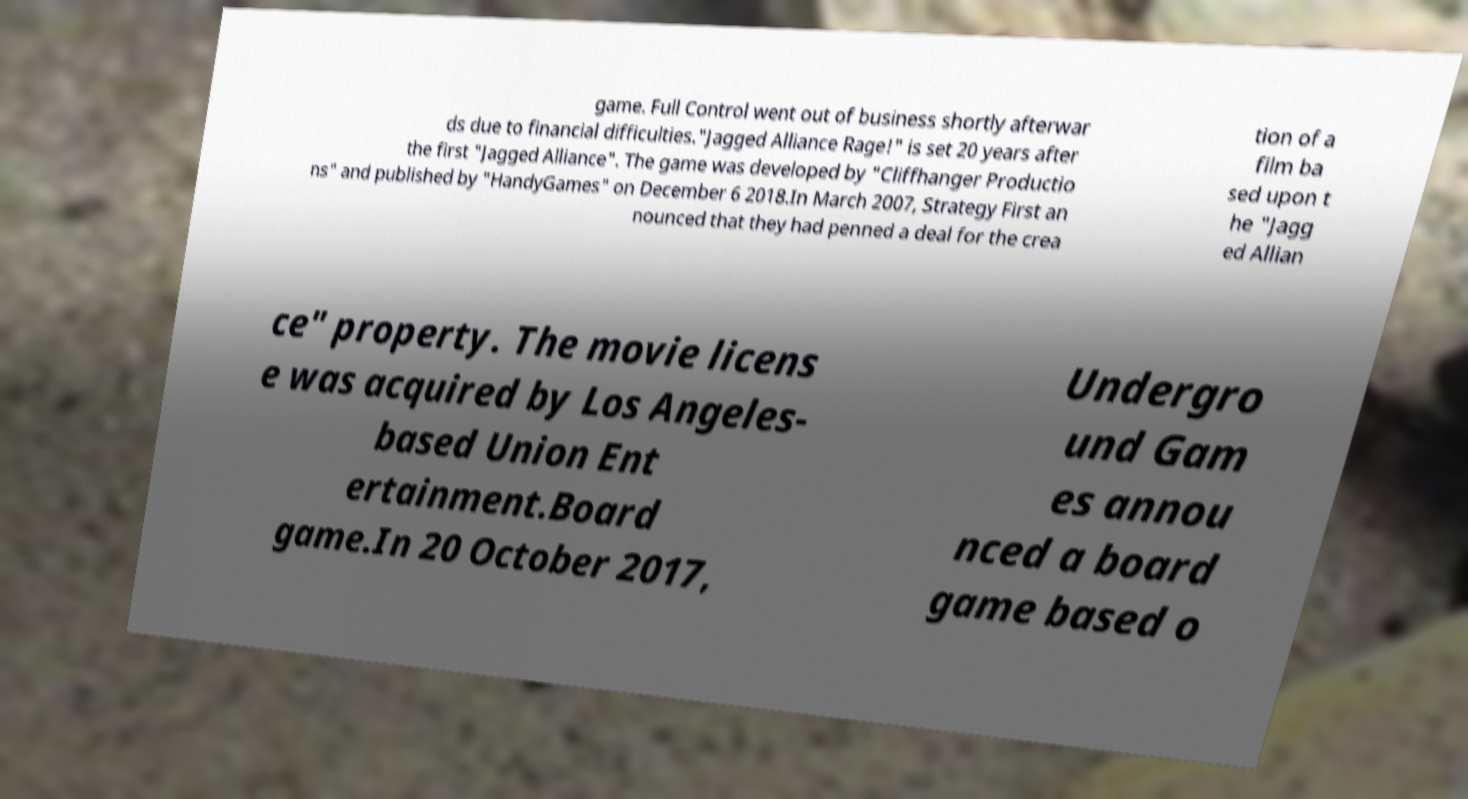Please read and relay the text visible in this image. What does it say? game. Full Control went out of business shortly afterwar ds due to financial difficulties."Jagged Alliance Rage!" is set 20 years after the first "Jagged Alliance". The game was developed by "Cliffhanger Productio ns" and published by "HandyGames" on December 6 2018.In March 2007, Strategy First an nounced that they had penned a deal for the crea tion of a film ba sed upon t he "Jagg ed Allian ce" property. The movie licens e was acquired by Los Angeles- based Union Ent ertainment.Board game.In 20 October 2017, Undergro und Gam es annou nced a board game based o 